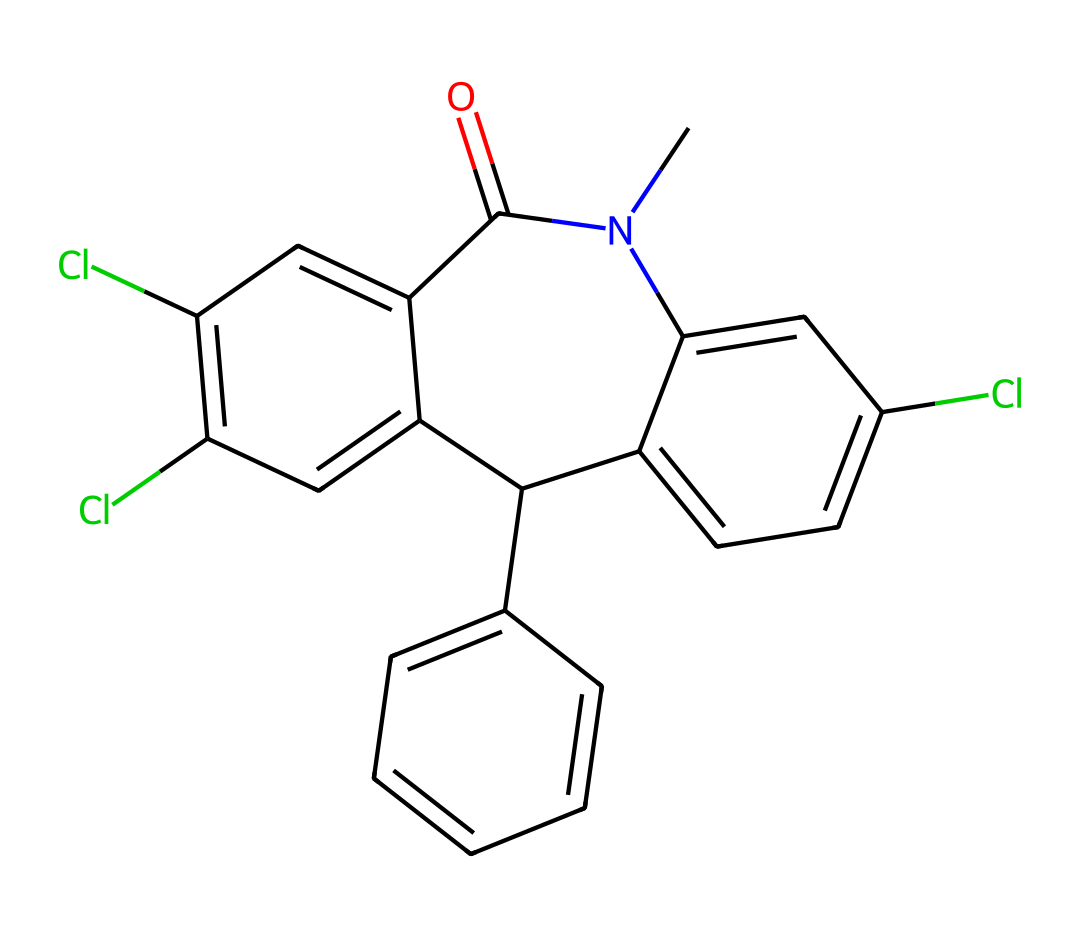What is the core structure of this chemical? The core structure of this chemical features a benzodiazepine framework, identifiable by the fused benzene and azepine rings. This configuration is typical for compounds in this drug class, crucial for their pharmacological effects.
Answer: benzodiazepine How many chlorine atoms are present in this structure? By inspecting the chemical structure, two chlorine substituents are clearly visible on the benzene rings, indicating the presence of two chlorine atoms.
Answer: two What type of functional group is present in this drug? The structure shows an amide functional group (–C(=O)N–), characterized by the carbonyl (C=O) adjacent to a nitrogen atom. This is significant as it can affect the compound's solubility and activity.
Answer: amide What is the total number of aromatic rings in this structure? The structure contains three aromatic rings. These are identified by the alternating double bonds and the hexagonal shape characteristic of aromatic compounds, contributing to the drug's stability and interactions.
Answer: three Does this compound contain a nitrogen atom? A careful examination of the structure reveals one nitrogen atom present, which is part of the amide group, indicating that this molecule belongs to the nitrogenous compound category often found in pharmaceuticals.
Answer: one In which segment of the structure can we find the amide functional group? The amide functional group can be located near the center of the structure, specifically between the carbon atom connected to two aromatic rings and the nitrogen atom. This placement is essential for the compound's biological properties.
Answer: near the center 